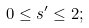<formula> <loc_0><loc_0><loc_500><loc_500>0 \leq s ^ { \prime } \leq 2 ;</formula> 